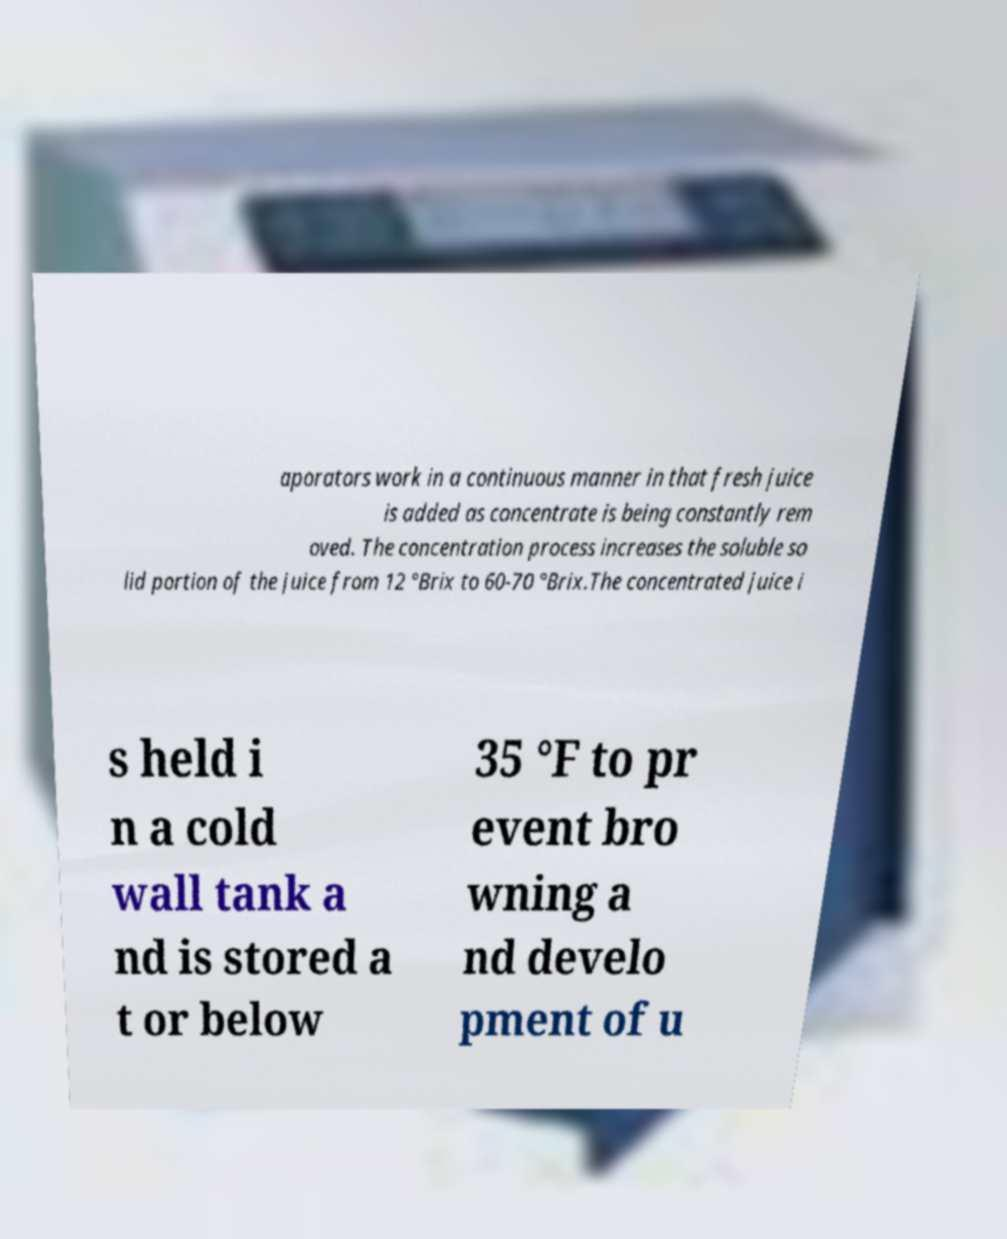There's text embedded in this image that I need extracted. Can you transcribe it verbatim? aporators work in a continuous manner in that fresh juice is added as concentrate is being constantly rem oved. The concentration process increases the soluble so lid portion of the juice from 12 °Brix to 60-70 °Brix.The concentrated juice i s held i n a cold wall tank a nd is stored a t or below 35 °F to pr event bro wning a nd develo pment of u 